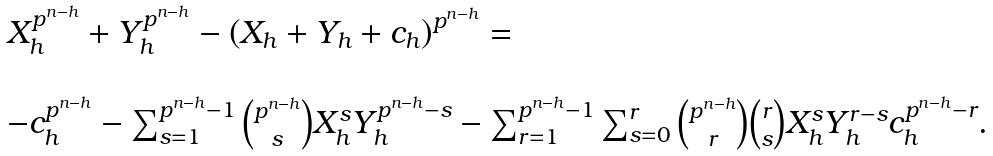<formula> <loc_0><loc_0><loc_500><loc_500>\begin{array} { l } X _ { h } ^ { p ^ { n - h } } + Y _ { h } ^ { p ^ { n - h } } - \left ( X _ { h } + Y _ { h } + c _ { h } \right ) ^ { p ^ { n - h } } = \\ \\ - c _ { h } ^ { p ^ { n - h } } - \sum _ { s = 1 } ^ { p ^ { n - h } - 1 } { p ^ { n - h } \choose s } X _ { h } ^ { s } Y _ { h } ^ { p ^ { n - h } - s } - \sum _ { r = 1 } ^ { p ^ { n - h } - 1 } \sum _ { s = 0 } ^ { r } { p ^ { n - h } \choose r } { r \choose s } X _ { h } ^ { s } Y _ { h } ^ { r - s } c _ { h } ^ { p ^ { n - h } - r } . \end{array}</formula> 